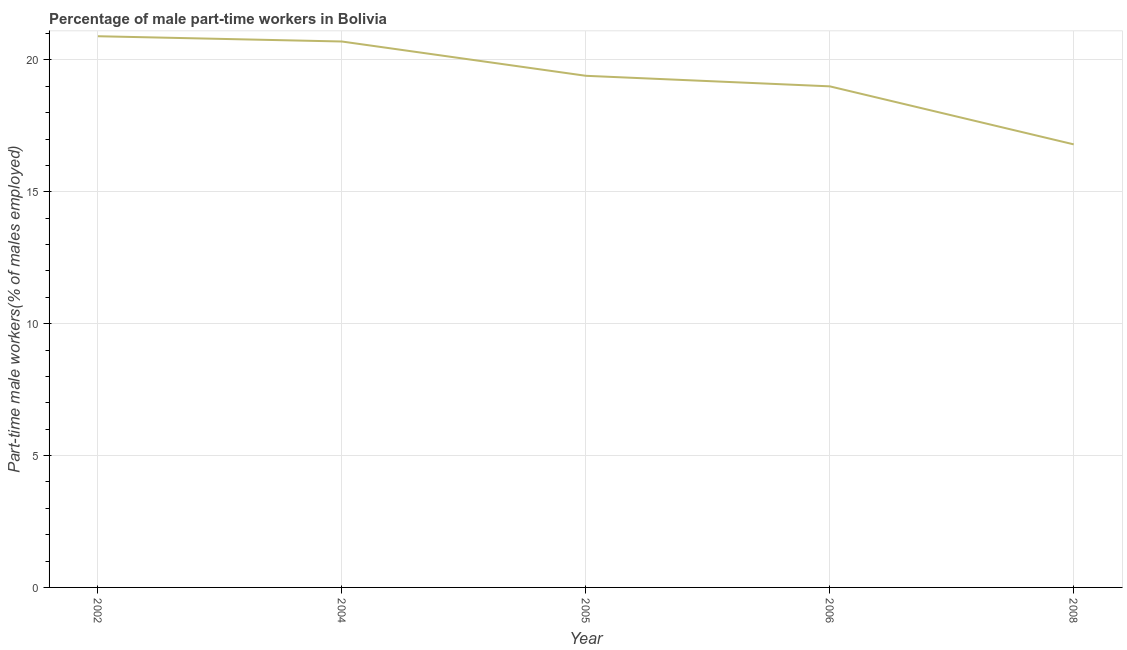What is the percentage of part-time male workers in 2008?
Provide a succinct answer. 16.8. Across all years, what is the maximum percentage of part-time male workers?
Keep it short and to the point. 20.9. Across all years, what is the minimum percentage of part-time male workers?
Give a very brief answer. 16.8. What is the sum of the percentage of part-time male workers?
Offer a terse response. 96.8. What is the difference between the percentage of part-time male workers in 2004 and 2008?
Your answer should be very brief. 3.9. What is the average percentage of part-time male workers per year?
Make the answer very short. 19.36. What is the median percentage of part-time male workers?
Offer a very short reply. 19.4. Do a majority of the years between 2005 and 2008 (inclusive) have percentage of part-time male workers greater than 12 %?
Ensure brevity in your answer.  Yes. What is the ratio of the percentage of part-time male workers in 2006 to that in 2008?
Provide a short and direct response. 1.13. Is the difference between the percentage of part-time male workers in 2004 and 2005 greater than the difference between any two years?
Your answer should be compact. No. What is the difference between the highest and the second highest percentage of part-time male workers?
Provide a succinct answer. 0.2. What is the difference between the highest and the lowest percentage of part-time male workers?
Give a very brief answer. 4.1. In how many years, is the percentage of part-time male workers greater than the average percentage of part-time male workers taken over all years?
Ensure brevity in your answer.  3. Does the percentage of part-time male workers monotonically increase over the years?
Make the answer very short. No. How many years are there in the graph?
Give a very brief answer. 5. Does the graph contain any zero values?
Your answer should be compact. No. What is the title of the graph?
Make the answer very short. Percentage of male part-time workers in Bolivia. What is the label or title of the X-axis?
Your answer should be very brief. Year. What is the label or title of the Y-axis?
Your response must be concise. Part-time male workers(% of males employed). What is the Part-time male workers(% of males employed) of 2002?
Your answer should be very brief. 20.9. What is the Part-time male workers(% of males employed) in 2004?
Your response must be concise. 20.7. What is the Part-time male workers(% of males employed) of 2005?
Ensure brevity in your answer.  19.4. What is the Part-time male workers(% of males employed) in 2008?
Your response must be concise. 16.8. What is the difference between the Part-time male workers(% of males employed) in 2004 and 2005?
Offer a very short reply. 1.3. What is the difference between the Part-time male workers(% of males employed) in 2004 and 2006?
Make the answer very short. 1.7. What is the difference between the Part-time male workers(% of males employed) in 2005 and 2006?
Provide a short and direct response. 0.4. What is the difference between the Part-time male workers(% of males employed) in 2006 and 2008?
Keep it short and to the point. 2.2. What is the ratio of the Part-time male workers(% of males employed) in 2002 to that in 2005?
Give a very brief answer. 1.08. What is the ratio of the Part-time male workers(% of males employed) in 2002 to that in 2006?
Provide a succinct answer. 1.1. What is the ratio of the Part-time male workers(% of males employed) in 2002 to that in 2008?
Your response must be concise. 1.24. What is the ratio of the Part-time male workers(% of males employed) in 2004 to that in 2005?
Provide a short and direct response. 1.07. What is the ratio of the Part-time male workers(% of males employed) in 2004 to that in 2006?
Offer a terse response. 1.09. What is the ratio of the Part-time male workers(% of males employed) in 2004 to that in 2008?
Provide a succinct answer. 1.23. What is the ratio of the Part-time male workers(% of males employed) in 2005 to that in 2008?
Your answer should be compact. 1.16. What is the ratio of the Part-time male workers(% of males employed) in 2006 to that in 2008?
Offer a very short reply. 1.13. 